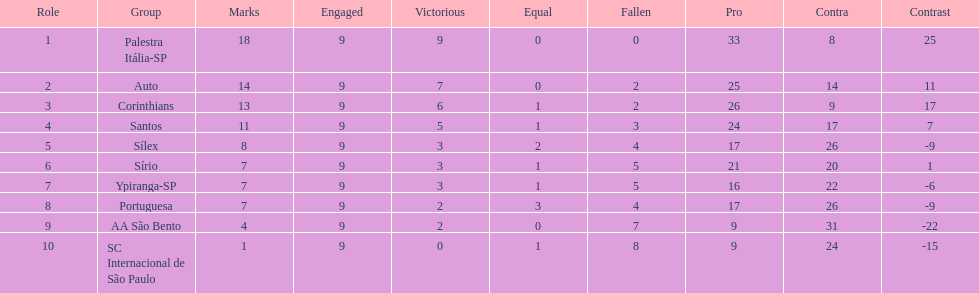Which team was the only team that was undefeated? Palestra Itália-SP. 